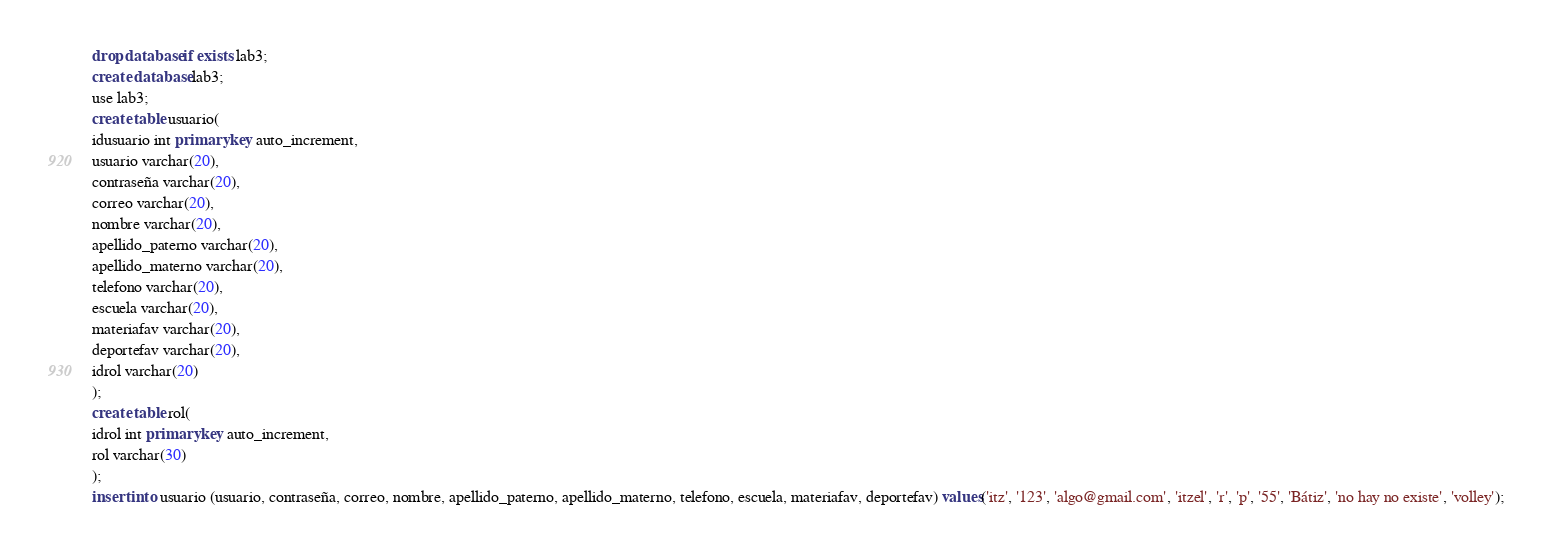<code> <loc_0><loc_0><loc_500><loc_500><_SQL_>drop database if exists lab3;
create database lab3;
use lab3;
create table usuario(
idusuario int primary key auto_increment,
usuario varchar(20),
contraseña varchar(20),
correo varchar(20),
nombre varchar(20),
apellido_paterno varchar(20),
apellido_materno varchar(20),
telefono varchar(20),
escuela varchar(20),
materiafav varchar(20),
deportefav varchar(20),
idrol varchar(20)
);
create table rol(
idrol int primary key auto_increment,
rol varchar(30)
);
insert into usuario (usuario, contraseña, correo, nombre, apellido_paterno, apellido_materno, telefono, escuela, materiafav, deportefav) values('itz', '123', 'algo@gmail.com', 'itzel', 'r', 'p', '55', 'Bátiz', 'no hay no existe', 'volley');</code> 